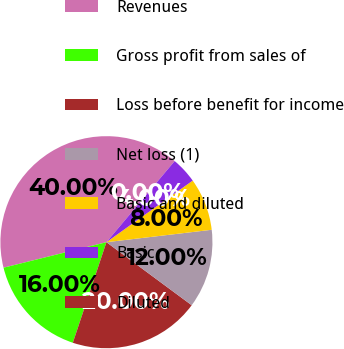<chart> <loc_0><loc_0><loc_500><loc_500><pie_chart><fcel>Revenues<fcel>Gross profit from sales of<fcel>Loss before benefit for income<fcel>Net loss (1)<fcel>Basic and diluted<fcel>Basic<fcel>Diluted<nl><fcel>40.0%<fcel>16.0%<fcel>20.0%<fcel>12.0%<fcel>8.0%<fcel>4.0%<fcel>0.0%<nl></chart> 